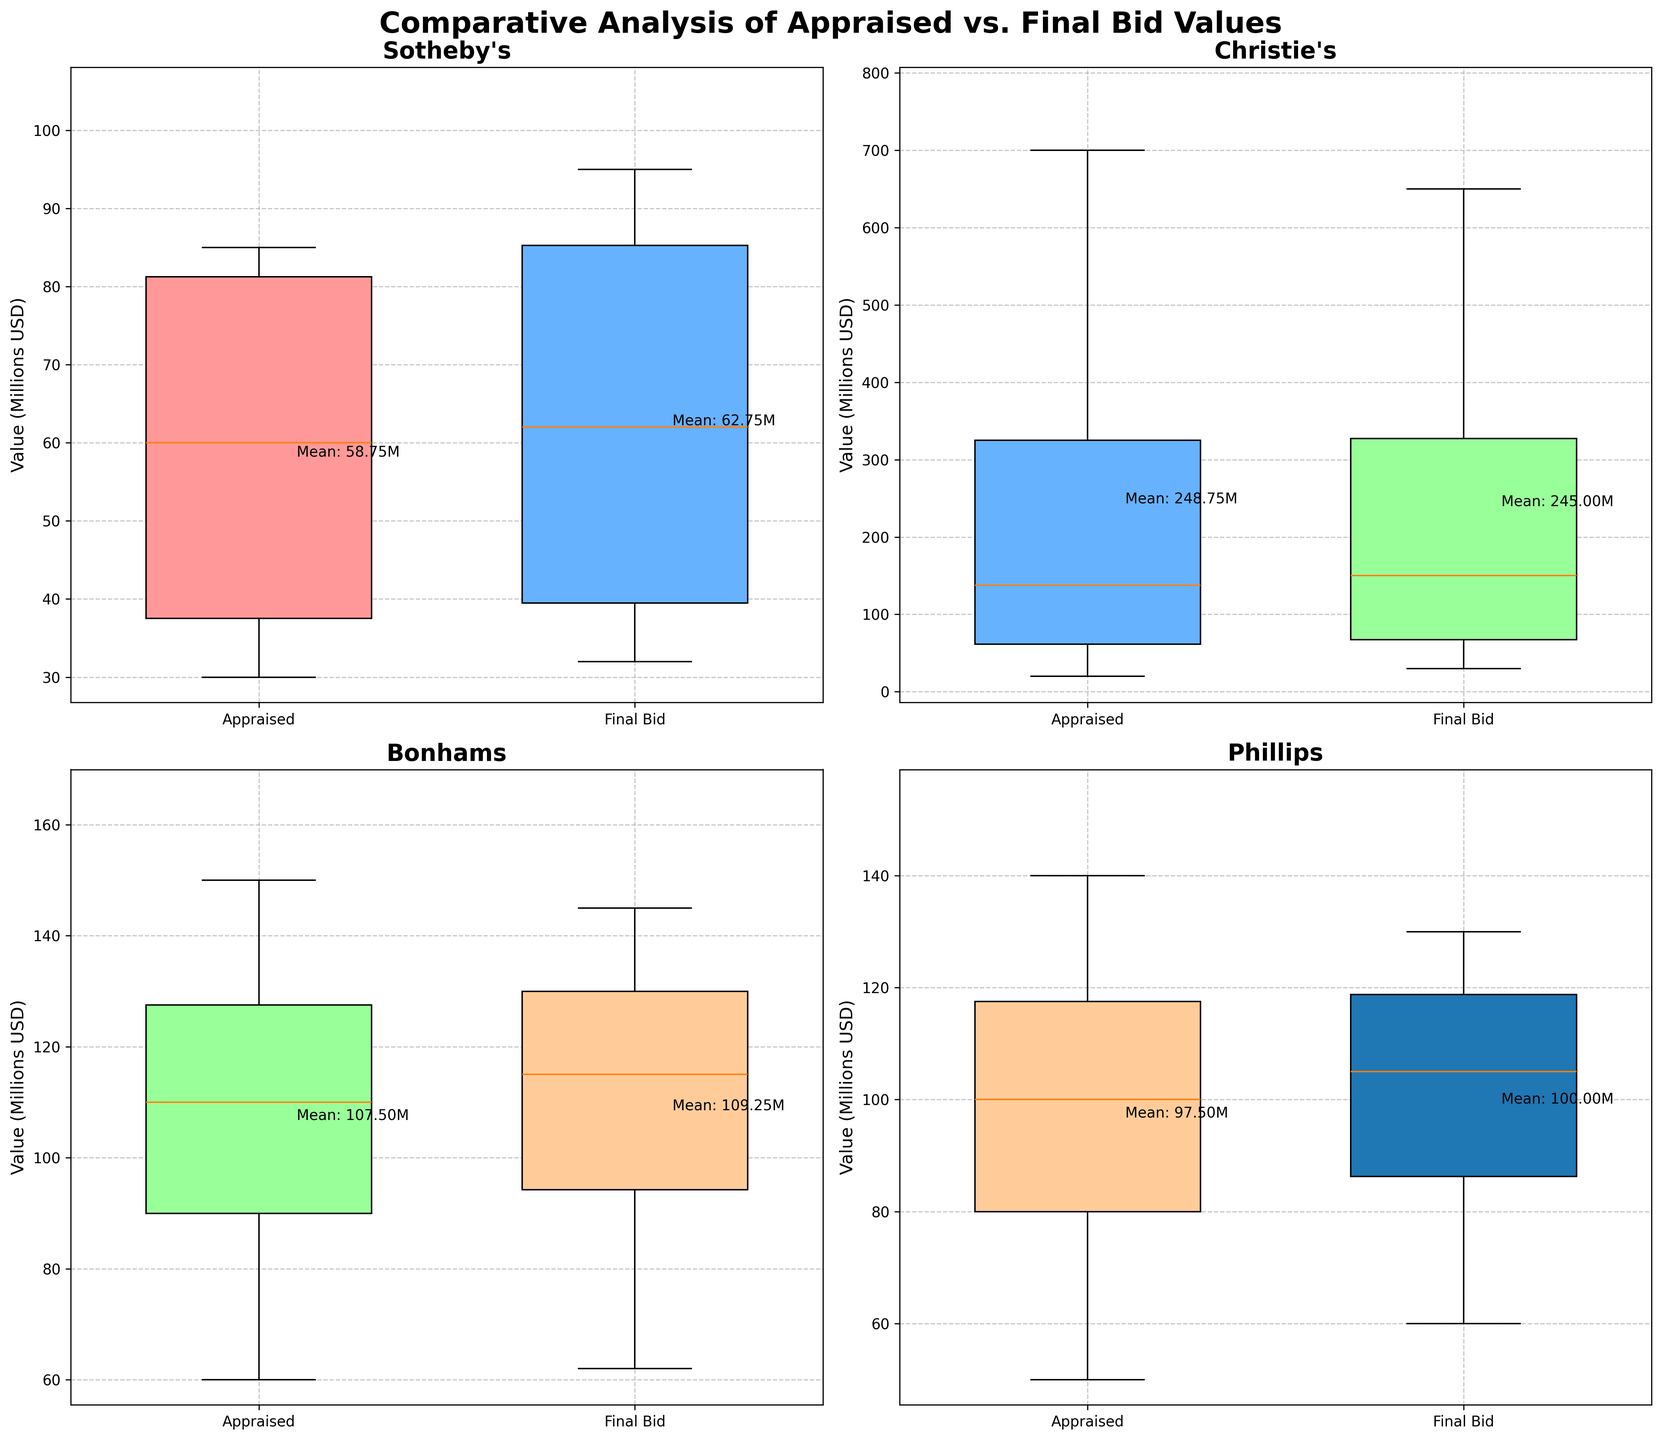What is the title of the figure? The title is prominently displayed at the top of the figure, formatting it to include all uppercase and bold text to ensure it catches the audience's attention. The title reads "Comparative Analysis of Appraised vs. Final Bid Values".
Answer: Comparative Analysis of Appraised vs. Final Bid Values How many auction houses are represented in the figure? Each subplot represents a separate auction house. In total, there are four subplots, each labeled with a unique auction house. The auction houses listed are Sotheby's, Christie's, Bonhams, and Phillips.
Answer: Four What are the labels on the x-axis of each subplot? The x-axis of each subplot has two specific labels. These labels are placed below the respective box plots, and read 'Appraised' for the first box plot and 'Final Bid' for the second box plot in each subplot.
Answer: Appraised and Final Bid Which auction house has high outliers in both Appraised and Final Bid values? The outliers are identifiable by small disconnected dots or markers in the box plots. In the subplot titled Christie's, small circles appear above both the 'Appraised' and 'Final Bid' box plots, indicating the presence of outliers.
Answer: Christie's Which auction house has a higher median value for Final Bid compared to its corresponding median Appraised Value? By examining the thick black line in the center of the box plots indicative of the medians, we note that in the subplot for Christie's, the median of the 'Final Bid' is positioned above that of the 'Appraised' value. This indicates a higher median for the final bid.
Answer: Christie's How many auction houses have a mean for both Appraised and Final Bid values shared on the figure? As seen from the annotations directly to the right of the box plots in each subplot, we find that all four auction houses have means labeled for both the 'Appraised' and 'Final Bid' values. This totals four auction houses.
Answer: Four What is the approximate mean of the appraised value in the Christie's subplot? In the subplot titled Christie's, the mean for the 'Appraised Value' can be read directly from the text annotation. It closely reads 'Mean: 297.50M', implying 297.50 million USD.
Answer: 297.50M In which auction house subplot do the final bid values have less variability compared to the appraised values? Less variability is indicated by a shorter height of the box in the box plot. Within the subplot for Bonhams, the box representing final bid values is notably shorter compared to the appraised values box — indicating less variability for final bid values.
Answer: Bonhams 